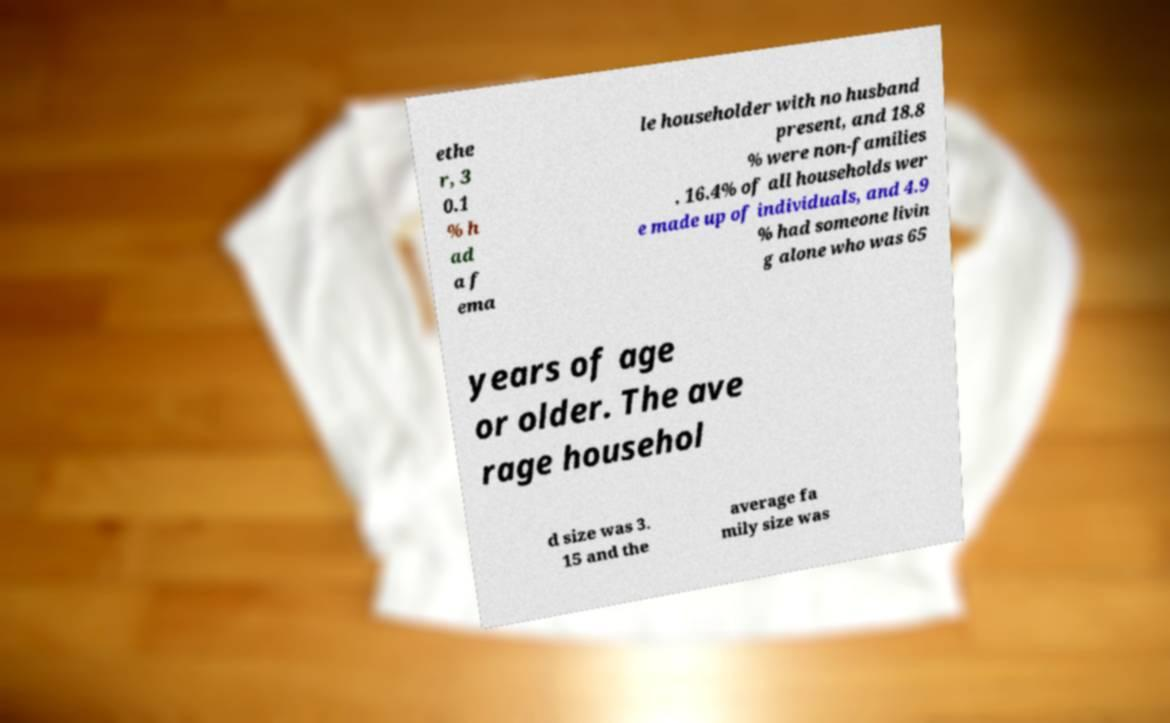For documentation purposes, I need the text within this image transcribed. Could you provide that? ethe r, 3 0.1 % h ad a f ema le householder with no husband present, and 18.8 % were non-families . 16.4% of all households wer e made up of individuals, and 4.9 % had someone livin g alone who was 65 years of age or older. The ave rage househol d size was 3. 15 and the average fa mily size was 